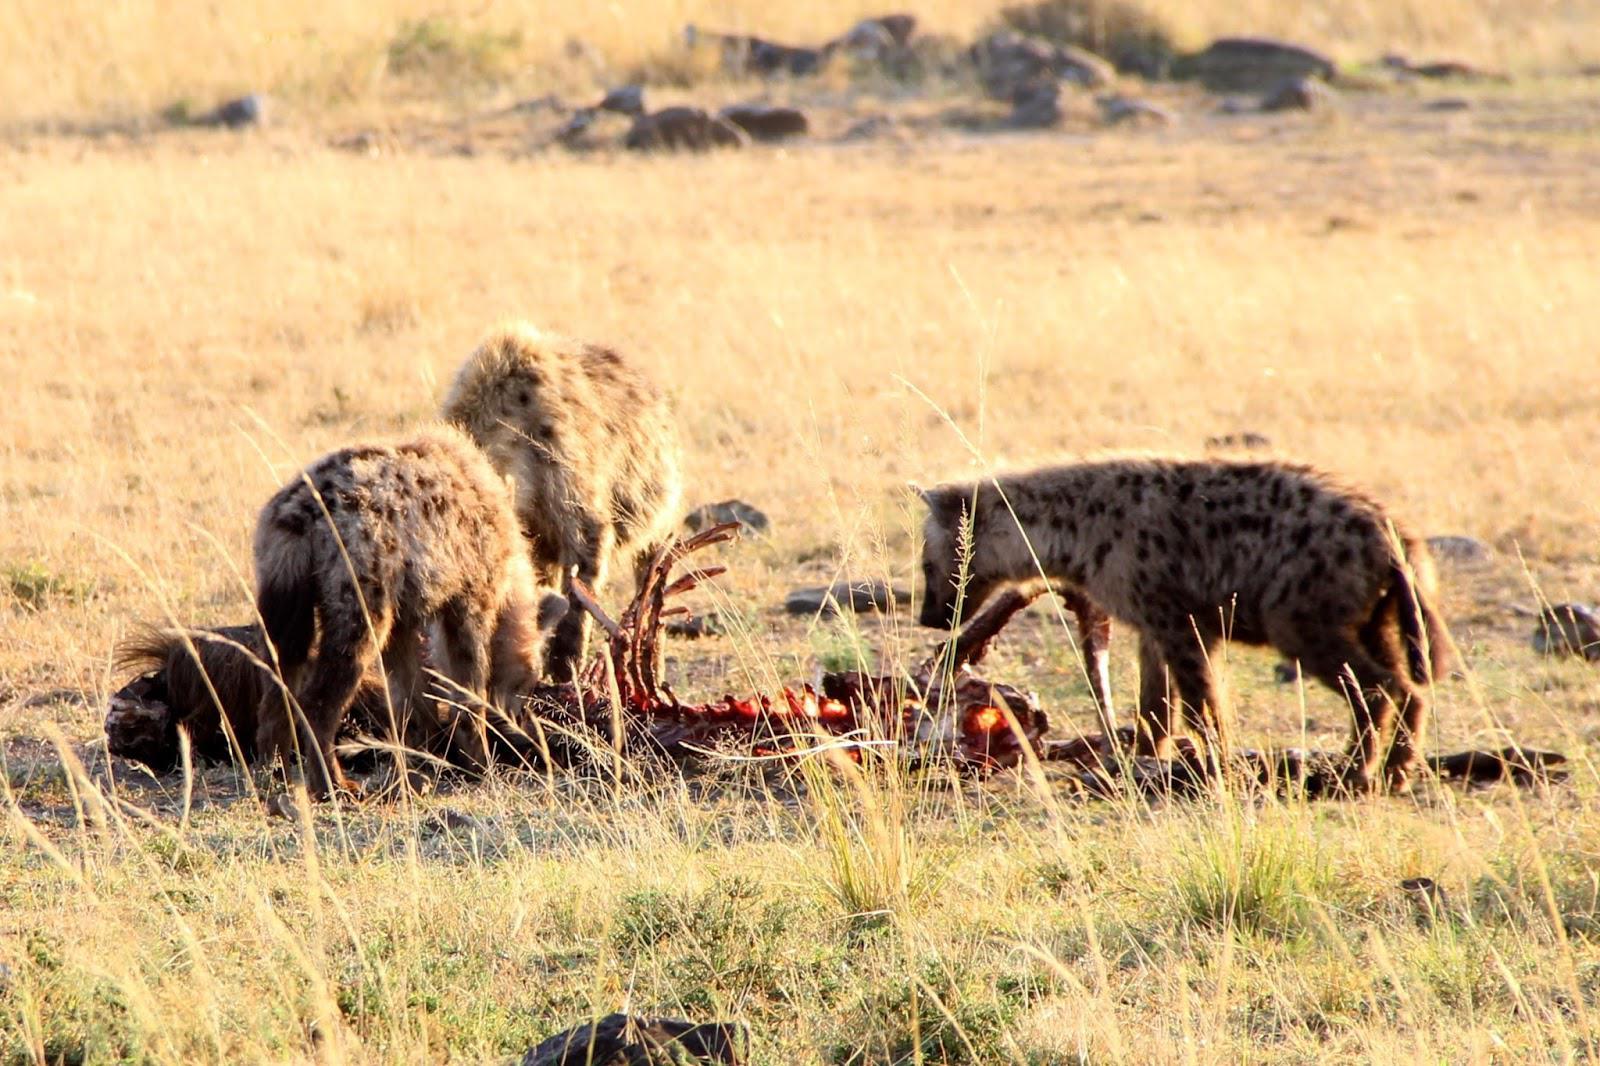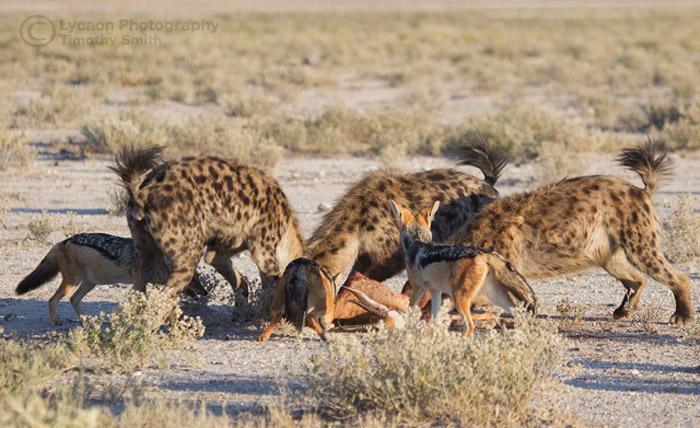The first image is the image on the left, the second image is the image on the right. Assess this claim about the two images: "The right image includes at least one jackal near at least two spotted hyenas.". Correct or not? Answer yes or no. Yes. The first image is the image on the left, the second image is the image on the right. Evaluate the accuracy of this statement regarding the images: "There are hyenas feasting on a dead animal.". Is it true? Answer yes or no. Yes. 